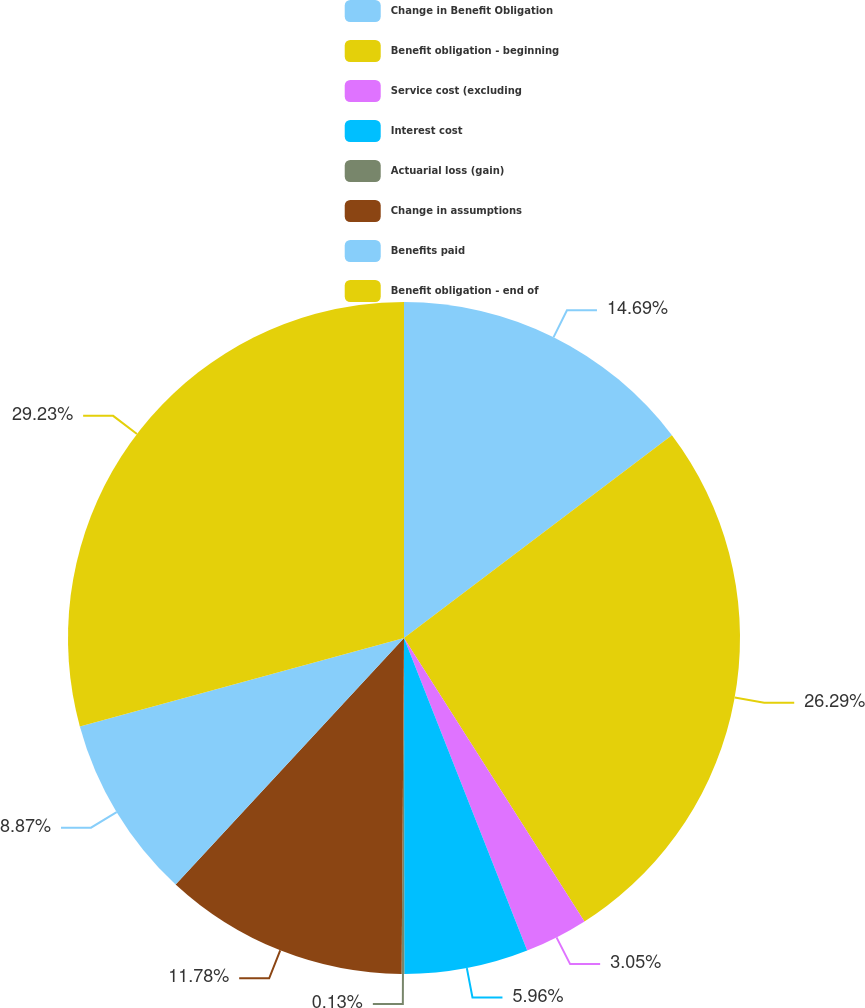Convert chart. <chart><loc_0><loc_0><loc_500><loc_500><pie_chart><fcel>Change in Benefit Obligation<fcel>Benefit obligation - beginning<fcel>Service cost (excluding<fcel>Interest cost<fcel>Actuarial loss (gain)<fcel>Change in assumptions<fcel>Benefits paid<fcel>Benefit obligation - end of<nl><fcel>14.69%<fcel>26.29%<fcel>3.05%<fcel>5.96%<fcel>0.13%<fcel>11.78%<fcel>8.87%<fcel>29.24%<nl></chart> 